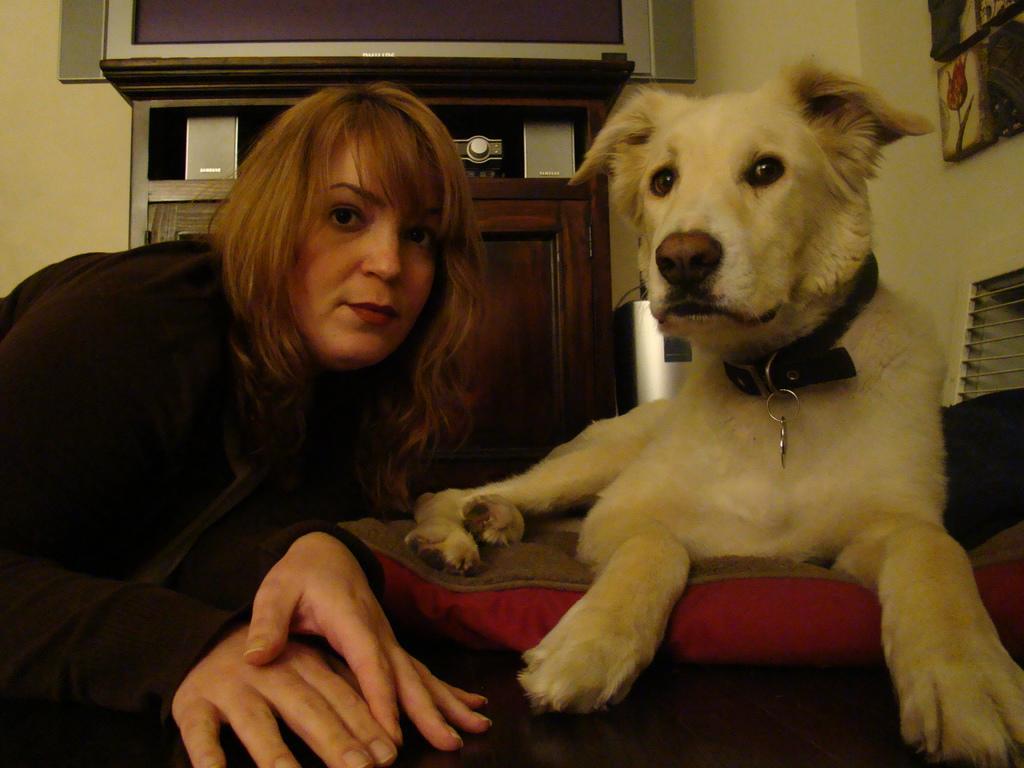How would you summarize this image in a sentence or two? In this image there is a dog sitting on a sofa, beside the dog there is a lady, in the background there is a wall and there is a cabinet, on that cabinet there is a TV and there are few objects, in the top right there are photo frames. 